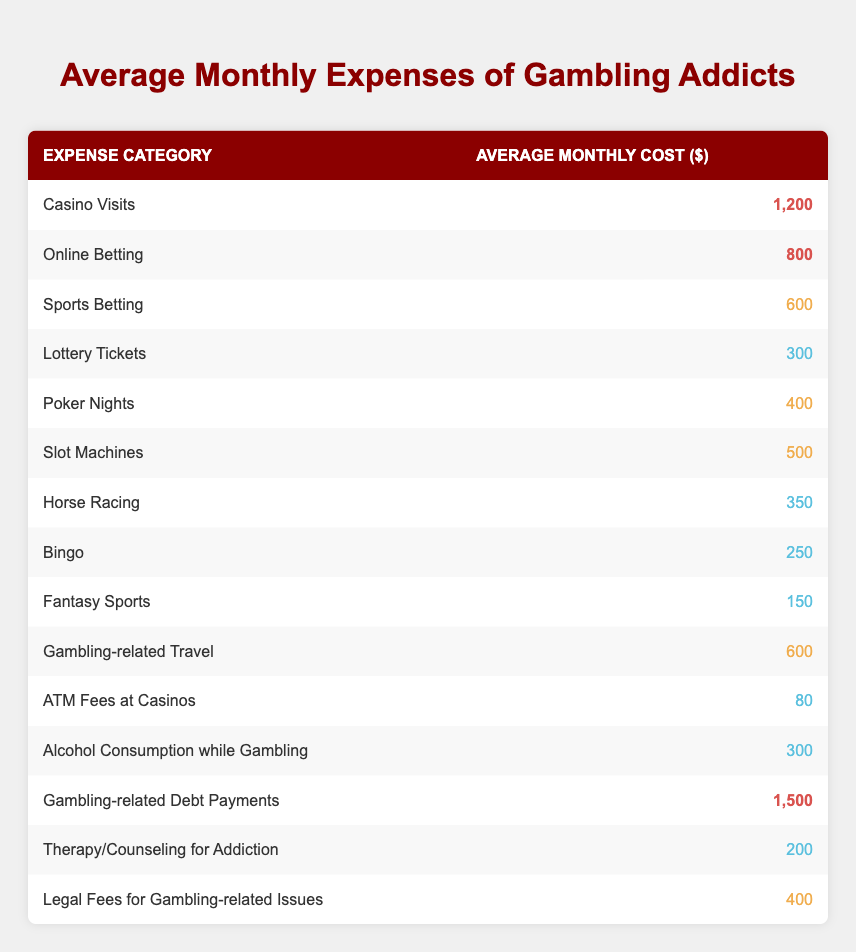What is the average monthly cost for gambling-related debt payments? The table lists the average monthly cost for gambling-related debt payments as 1,500 dollars.
Answer: 1,500 Which expense category has the highest average monthly cost? The table indicates that gambling-related debt payments have the highest average monthly cost at 1,500 dollars.
Answer: Gambling-related debt payments How much do gambling addicts spend on online betting compared to casino visits? The average monthly cost for online betting is 800 dollars, while casino visits are 1,200 dollars. To compare, you can see that online betting costs 400 dollars less than casino visits.
Answer: 400 less Are therapy and counseling expenses higher than legal fees for gambling-related issues? The average monthly cost for therapy/counseling is listed as 200 dollars, while legal fees are 400 dollars, so therapy expenses are lower.
Answer: No What is the total monthly cost for all forms of gambling combined (excluding therapy and legal fees)? To find the total for all forms of gambling excluding therapy and legal fees: 1,200 + 800 + 600 + 300 + 400 + 500 + 350 + 250 + 150 + 600 + 80 + 300 + 1,500 = 5,290 dollars.
Answer: 5,290 What is the median cost of the gambling expenses listed in the table? To find the median, first, we list the expenses: 80, 150, 200, 250, 300, 300, 350, 400, 400, 500, 600, 600, 800, 1,200, 1,500. There are 15 values, and the median is the 8th value, which is 400 dollars.
Answer: 400 How much less is spent on fantasy sports compared to horse racing? The average cost for fantasy sports is 150 dollars, and for horse racing, it is 350 dollars. The difference is 350 - 150 = 200 dollars.
Answer: 200 Is the average cost for gambling-related travel higher than the combined cost of lottery tickets and bingo? Gambling-related travel costs 600 dollars. The cost for lottery tickets is 300 dollars and bingo is 250 dollars. Together they total 300 + 250 = 550 dollars. Since 600 is greater than 550, the statement is true.
Answer: Yes 